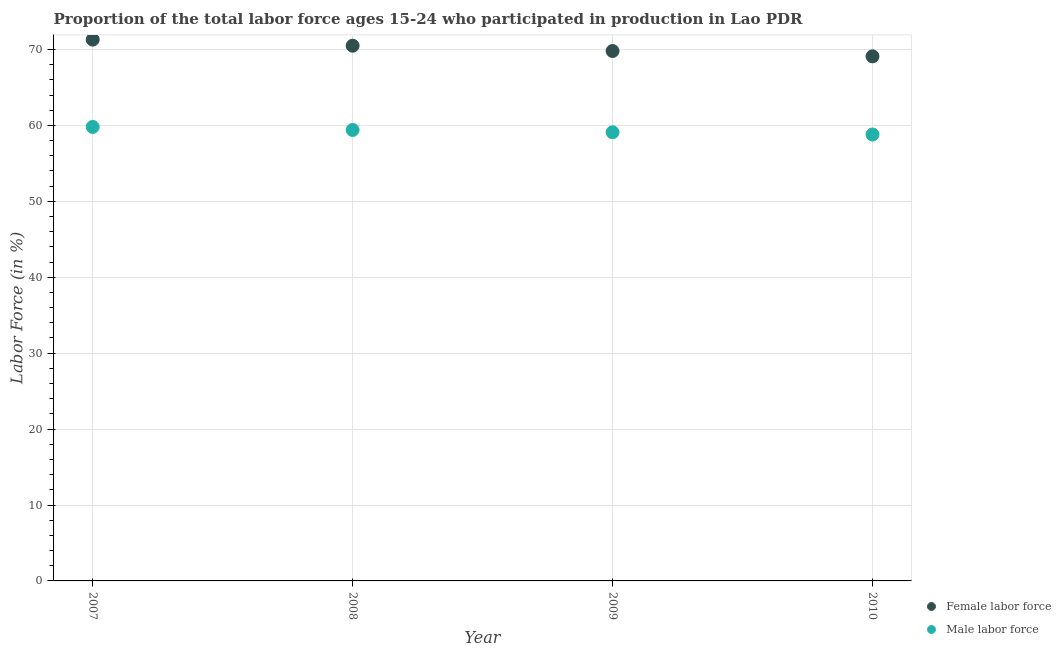Is the number of dotlines equal to the number of legend labels?
Ensure brevity in your answer.  Yes. What is the percentage of male labour force in 2009?
Make the answer very short. 59.1. Across all years, what is the maximum percentage of male labour force?
Provide a succinct answer. 59.8. Across all years, what is the minimum percentage of male labour force?
Offer a terse response. 58.8. In which year was the percentage of male labour force maximum?
Your answer should be compact. 2007. What is the total percentage of male labour force in the graph?
Provide a succinct answer. 237.1. What is the difference between the percentage of male labour force in 2007 and that in 2010?
Your answer should be very brief. 1. What is the difference between the percentage of female labor force in 2007 and the percentage of male labour force in 2008?
Your response must be concise. 11.9. What is the average percentage of male labour force per year?
Make the answer very short. 59.27. In the year 2009, what is the difference between the percentage of female labor force and percentage of male labour force?
Your answer should be very brief. 10.7. What is the ratio of the percentage of male labour force in 2007 to that in 2010?
Ensure brevity in your answer.  1.02. Is the difference between the percentage of female labor force in 2007 and 2008 greater than the difference between the percentage of male labour force in 2007 and 2008?
Make the answer very short. Yes. What is the difference between the highest and the second highest percentage of male labour force?
Offer a very short reply. 0.4. What is the difference between the highest and the lowest percentage of male labour force?
Keep it short and to the point. 1. In how many years, is the percentage of male labour force greater than the average percentage of male labour force taken over all years?
Offer a very short reply. 2. Does the percentage of female labor force monotonically increase over the years?
Make the answer very short. No. Is the percentage of female labor force strictly greater than the percentage of male labour force over the years?
Provide a succinct answer. Yes. Is the percentage of female labor force strictly less than the percentage of male labour force over the years?
Make the answer very short. No. How many dotlines are there?
Your answer should be compact. 2. What is the difference between two consecutive major ticks on the Y-axis?
Offer a terse response. 10. Does the graph contain grids?
Your answer should be very brief. Yes. Where does the legend appear in the graph?
Provide a short and direct response. Bottom right. How many legend labels are there?
Provide a succinct answer. 2. How are the legend labels stacked?
Your response must be concise. Vertical. What is the title of the graph?
Ensure brevity in your answer.  Proportion of the total labor force ages 15-24 who participated in production in Lao PDR. Does "Lowest 10% of population" appear as one of the legend labels in the graph?
Your answer should be compact. No. What is the label or title of the X-axis?
Your answer should be compact. Year. What is the Labor Force (in %) of Female labor force in 2007?
Provide a succinct answer. 71.3. What is the Labor Force (in %) of Male labor force in 2007?
Your answer should be very brief. 59.8. What is the Labor Force (in %) in Female labor force in 2008?
Your answer should be compact. 70.5. What is the Labor Force (in %) in Male labor force in 2008?
Your answer should be compact. 59.4. What is the Labor Force (in %) in Female labor force in 2009?
Ensure brevity in your answer.  69.8. What is the Labor Force (in %) in Male labor force in 2009?
Give a very brief answer. 59.1. What is the Labor Force (in %) in Female labor force in 2010?
Keep it short and to the point. 69.1. What is the Labor Force (in %) in Male labor force in 2010?
Provide a succinct answer. 58.8. Across all years, what is the maximum Labor Force (in %) of Female labor force?
Give a very brief answer. 71.3. Across all years, what is the maximum Labor Force (in %) of Male labor force?
Your response must be concise. 59.8. Across all years, what is the minimum Labor Force (in %) in Female labor force?
Your answer should be very brief. 69.1. Across all years, what is the minimum Labor Force (in %) in Male labor force?
Give a very brief answer. 58.8. What is the total Labor Force (in %) in Female labor force in the graph?
Keep it short and to the point. 280.7. What is the total Labor Force (in %) in Male labor force in the graph?
Give a very brief answer. 237.1. What is the difference between the Labor Force (in %) of Male labor force in 2007 and that in 2009?
Make the answer very short. 0.7. What is the difference between the Labor Force (in %) of Female labor force in 2007 and that in 2010?
Provide a succinct answer. 2.2. What is the difference between the Labor Force (in %) in Female labor force in 2008 and that in 2009?
Offer a terse response. 0.7. What is the difference between the Labor Force (in %) of Male labor force in 2008 and that in 2009?
Ensure brevity in your answer.  0.3. What is the difference between the Labor Force (in %) of Male labor force in 2008 and that in 2010?
Provide a short and direct response. 0.6. What is the difference between the Labor Force (in %) in Female labor force in 2008 and the Labor Force (in %) in Male labor force in 2009?
Provide a succinct answer. 11.4. What is the difference between the Labor Force (in %) of Female labor force in 2009 and the Labor Force (in %) of Male labor force in 2010?
Ensure brevity in your answer.  11. What is the average Labor Force (in %) of Female labor force per year?
Give a very brief answer. 70.17. What is the average Labor Force (in %) in Male labor force per year?
Keep it short and to the point. 59.27. In the year 2007, what is the difference between the Labor Force (in %) in Female labor force and Labor Force (in %) in Male labor force?
Ensure brevity in your answer.  11.5. In the year 2009, what is the difference between the Labor Force (in %) of Female labor force and Labor Force (in %) of Male labor force?
Make the answer very short. 10.7. In the year 2010, what is the difference between the Labor Force (in %) of Female labor force and Labor Force (in %) of Male labor force?
Your answer should be compact. 10.3. What is the ratio of the Labor Force (in %) in Female labor force in 2007 to that in 2008?
Offer a terse response. 1.01. What is the ratio of the Labor Force (in %) in Male labor force in 2007 to that in 2008?
Offer a terse response. 1.01. What is the ratio of the Labor Force (in %) in Female labor force in 2007 to that in 2009?
Your response must be concise. 1.02. What is the ratio of the Labor Force (in %) in Male labor force in 2007 to that in 2009?
Your answer should be very brief. 1.01. What is the ratio of the Labor Force (in %) in Female labor force in 2007 to that in 2010?
Offer a terse response. 1.03. What is the ratio of the Labor Force (in %) in Female labor force in 2008 to that in 2010?
Provide a succinct answer. 1.02. What is the ratio of the Labor Force (in %) in Male labor force in 2008 to that in 2010?
Your answer should be compact. 1.01. What is the difference between the highest and the lowest Labor Force (in %) in Male labor force?
Ensure brevity in your answer.  1. 